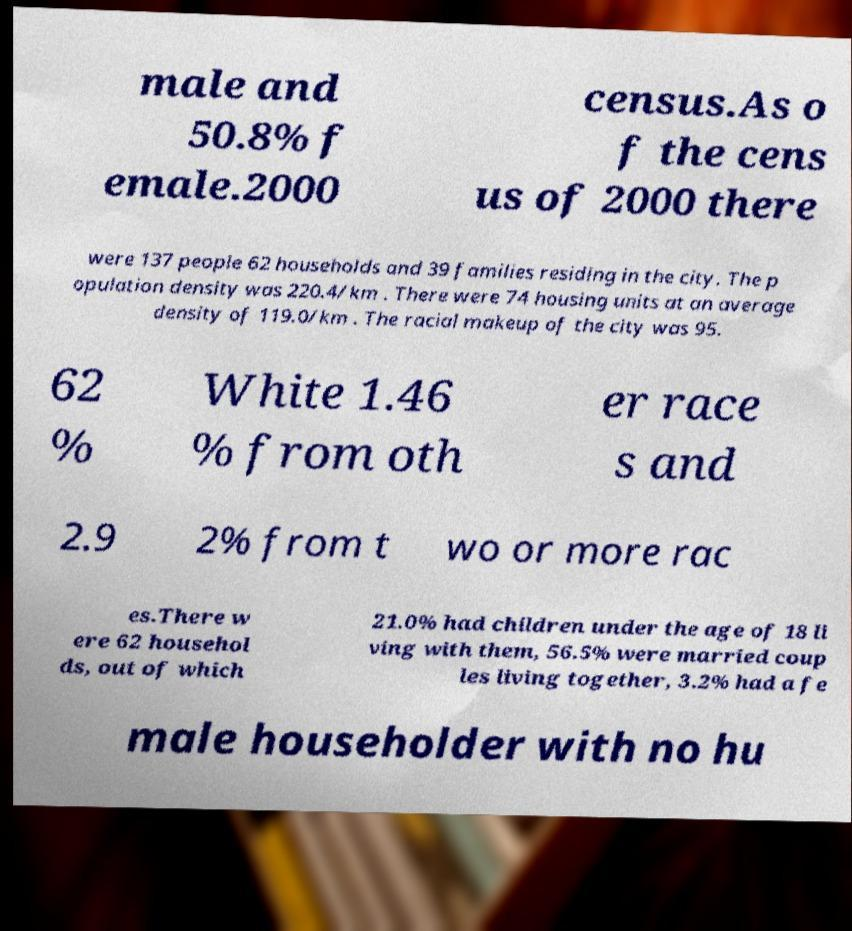For documentation purposes, I need the text within this image transcribed. Could you provide that? male and 50.8% f emale.2000 census.As o f the cens us of 2000 there were 137 people 62 households and 39 families residing in the city. The p opulation density was 220.4/km . There were 74 housing units at an average density of 119.0/km . The racial makeup of the city was 95. 62 % White 1.46 % from oth er race s and 2.9 2% from t wo or more rac es.There w ere 62 househol ds, out of which 21.0% had children under the age of 18 li ving with them, 56.5% were married coup les living together, 3.2% had a fe male householder with no hu 